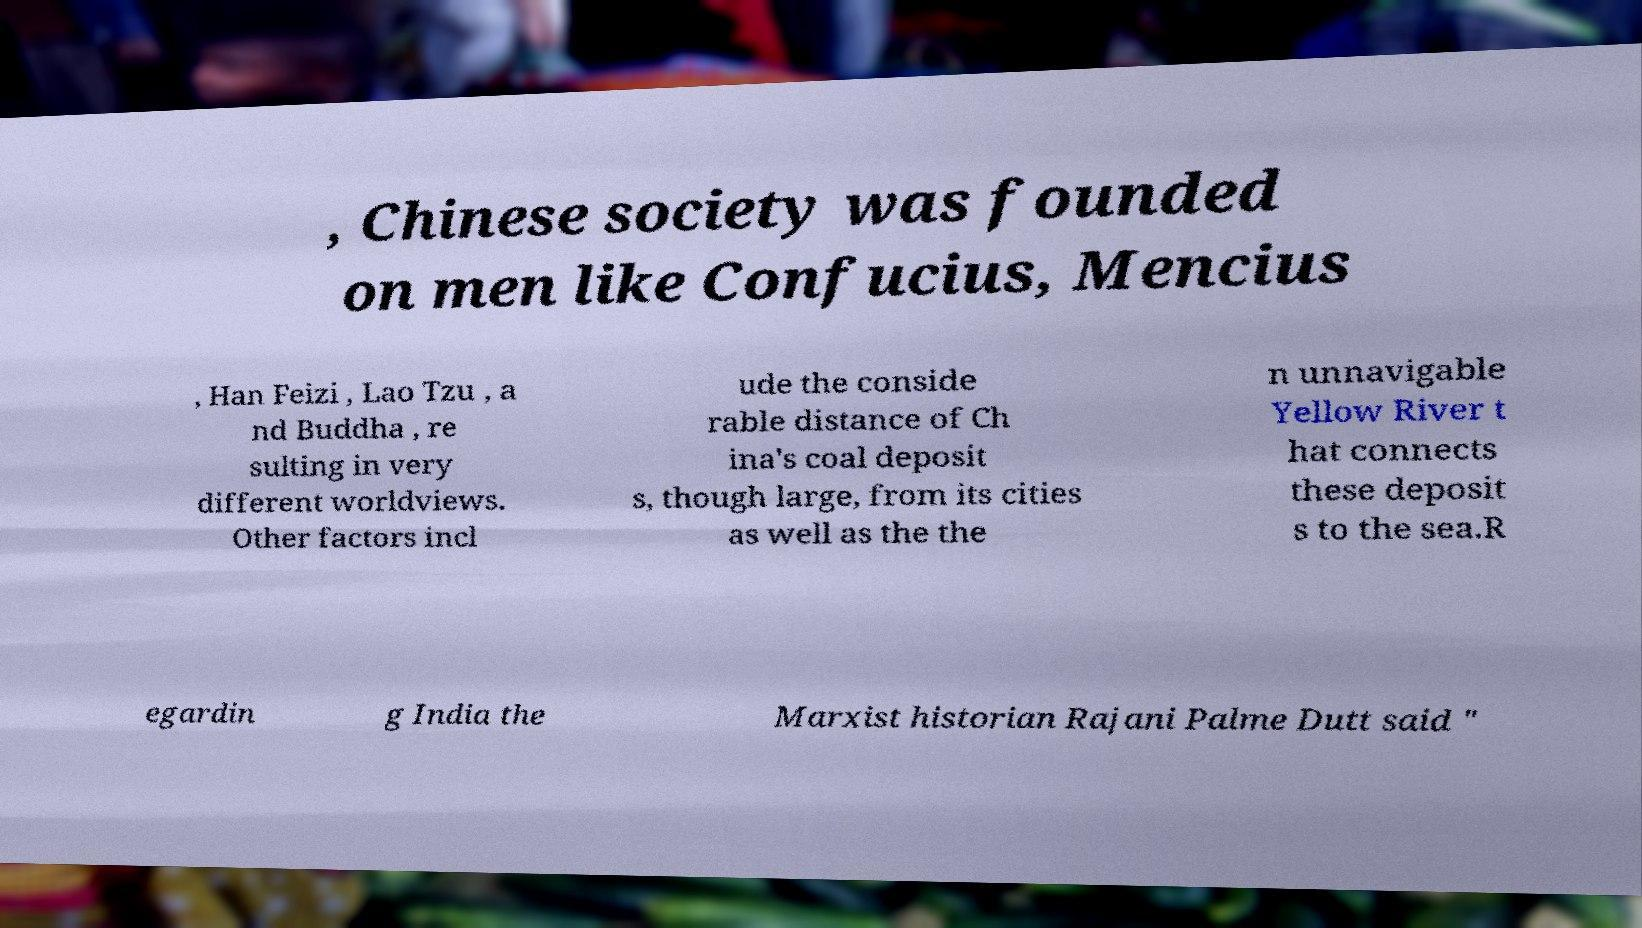Please identify and transcribe the text found in this image. , Chinese society was founded on men like Confucius, Mencius , Han Feizi , Lao Tzu , a nd Buddha , re sulting in very different worldviews. Other factors incl ude the conside rable distance of Ch ina's coal deposit s, though large, from its cities as well as the the n unnavigable Yellow River t hat connects these deposit s to the sea.R egardin g India the Marxist historian Rajani Palme Dutt said " 